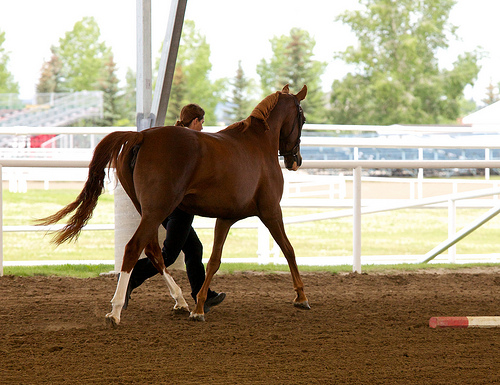<image>
Is there a horse to the left of the fence? No. The horse is not to the left of the fence. From this viewpoint, they have a different horizontal relationship. 